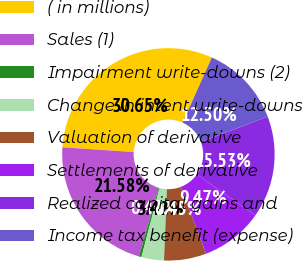Convert chart. <chart><loc_0><loc_0><loc_500><loc_500><pie_chart><fcel>( in millions)<fcel>Sales (1)<fcel>Impairment write-downs (2)<fcel>Change in intent write-downs<fcel>Valuation of derivative<fcel>Settlements of derivative<fcel>Realized capital gains and<fcel>Income tax benefit (expense)<nl><fcel>30.65%<fcel>21.58%<fcel>0.4%<fcel>3.42%<fcel>6.45%<fcel>9.47%<fcel>15.53%<fcel>12.5%<nl></chart> 